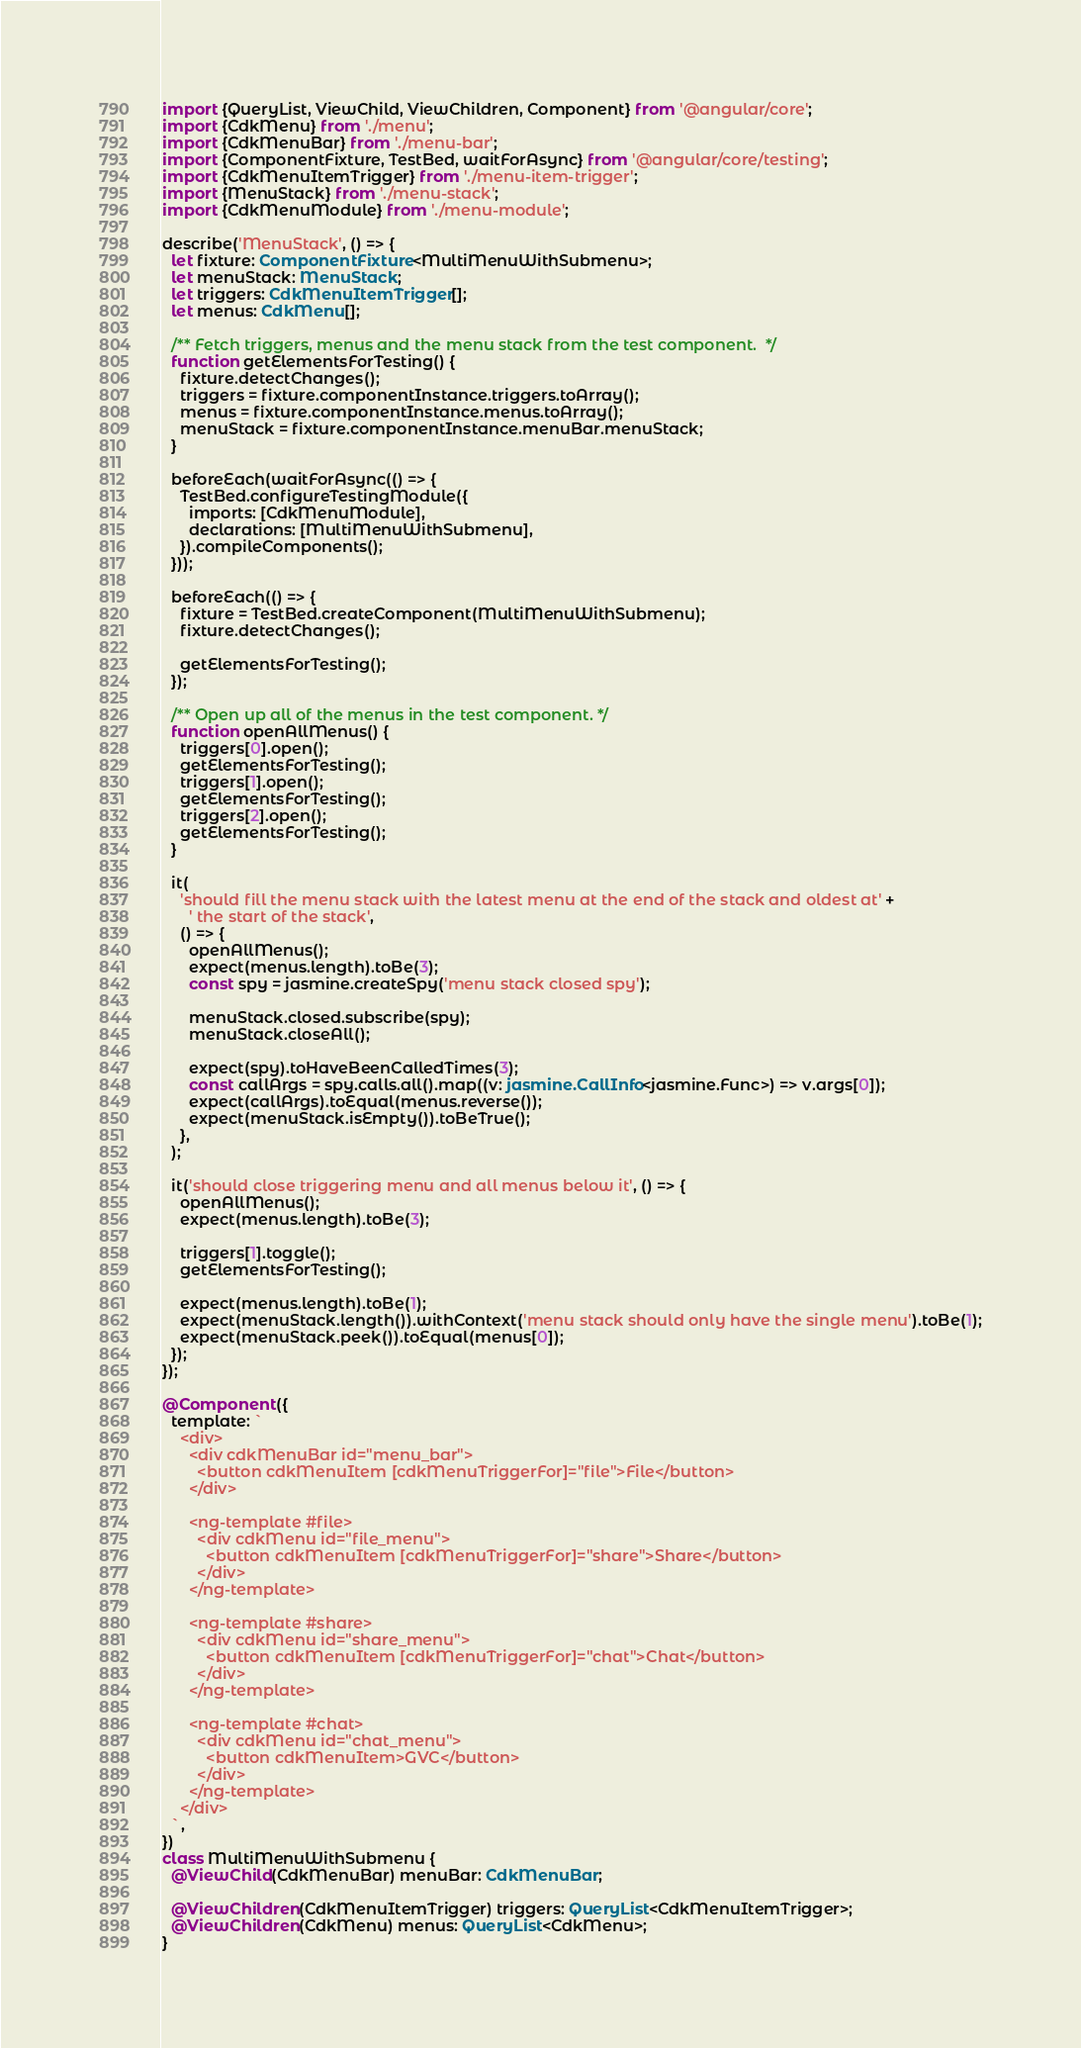<code> <loc_0><loc_0><loc_500><loc_500><_TypeScript_>import {QueryList, ViewChild, ViewChildren, Component} from '@angular/core';
import {CdkMenu} from './menu';
import {CdkMenuBar} from './menu-bar';
import {ComponentFixture, TestBed, waitForAsync} from '@angular/core/testing';
import {CdkMenuItemTrigger} from './menu-item-trigger';
import {MenuStack} from './menu-stack';
import {CdkMenuModule} from './menu-module';

describe('MenuStack', () => {
  let fixture: ComponentFixture<MultiMenuWithSubmenu>;
  let menuStack: MenuStack;
  let triggers: CdkMenuItemTrigger[];
  let menus: CdkMenu[];

  /** Fetch triggers, menus and the menu stack from the test component.  */
  function getElementsForTesting() {
    fixture.detectChanges();
    triggers = fixture.componentInstance.triggers.toArray();
    menus = fixture.componentInstance.menus.toArray();
    menuStack = fixture.componentInstance.menuBar.menuStack;
  }

  beforeEach(waitForAsync(() => {
    TestBed.configureTestingModule({
      imports: [CdkMenuModule],
      declarations: [MultiMenuWithSubmenu],
    }).compileComponents();
  }));

  beforeEach(() => {
    fixture = TestBed.createComponent(MultiMenuWithSubmenu);
    fixture.detectChanges();

    getElementsForTesting();
  });

  /** Open up all of the menus in the test component. */
  function openAllMenus() {
    triggers[0].open();
    getElementsForTesting();
    triggers[1].open();
    getElementsForTesting();
    triggers[2].open();
    getElementsForTesting();
  }

  it(
    'should fill the menu stack with the latest menu at the end of the stack and oldest at' +
      ' the start of the stack',
    () => {
      openAllMenus();
      expect(menus.length).toBe(3);
      const spy = jasmine.createSpy('menu stack closed spy');

      menuStack.closed.subscribe(spy);
      menuStack.closeAll();

      expect(spy).toHaveBeenCalledTimes(3);
      const callArgs = spy.calls.all().map((v: jasmine.CallInfo<jasmine.Func>) => v.args[0]);
      expect(callArgs).toEqual(menus.reverse());
      expect(menuStack.isEmpty()).toBeTrue();
    },
  );

  it('should close triggering menu and all menus below it', () => {
    openAllMenus();
    expect(menus.length).toBe(3);

    triggers[1].toggle();
    getElementsForTesting();

    expect(menus.length).toBe(1);
    expect(menuStack.length()).withContext('menu stack should only have the single menu').toBe(1);
    expect(menuStack.peek()).toEqual(menus[0]);
  });
});

@Component({
  template: `
    <div>
      <div cdkMenuBar id="menu_bar">
        <button cdkMenuItem [cdkMenuTriggerFor]="file">File</button>
      </div>

      <ng-template #file>
        <div cdkMenu id="file_menu">
          <button cdkMenuItem [cdkMenuTriggerFor]="share">Share</button>
        </div>
      </ng-template>

      <ng-template #share>
        <div cdkMenu id="share_menu">
          <button cdkMenuItem [cdkMenuTriggerFor]="chat">Chat</button>
        </div>
      </ng-template>

      <ng-template #chat>
        <div cdkMenu id="chat_menu">
          <button cdkMenuItem>GVC</button>
        </div>
      </ng-template>
    </div>
  `,
})
class MultiMenuWithSubmenu {
  @ViewChild(CdkMenuBar) menuBar: CdkMenuBar;

  @ViewChildren(CdkMenuItemTrigger) triggers: QueryList<CdkMenuItemTrigger>;
  @ViewChildren(CdkMenu) menus: QueryList<CdkMenu>;
}
</code> 